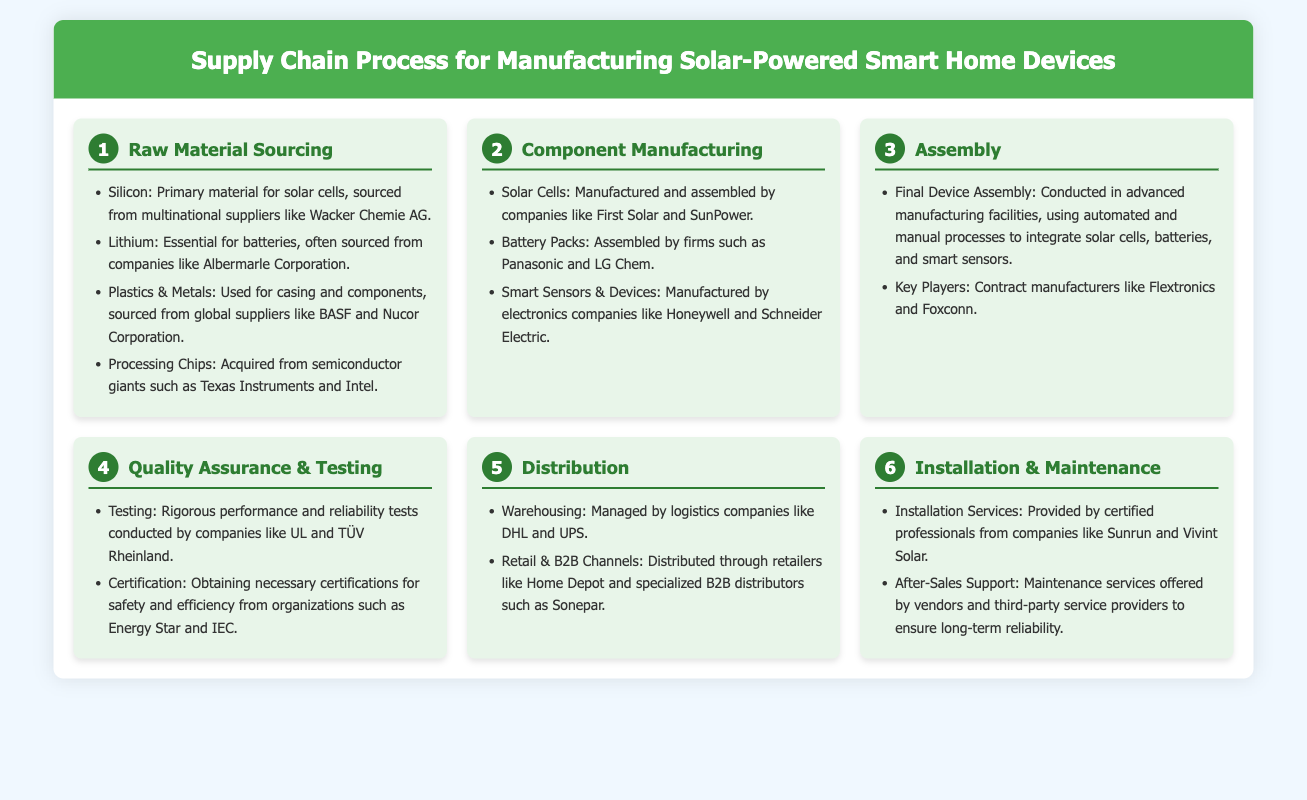What are the primary materials for solar cells? The primary materials for solar cells listed are Silicon, Lithium, Plastics & Metals, and Processing Chips.
Answer: Silicon, Lithium, Plastics & Metals, Processing Chips Which companies are involved in the manufacturing of solar cells? The companies mentioned that manufacture solar cells include First Solar and SunPower.
Answer: First Solar, SunPower What is the third step in the supply chain process? The third step in the supply chain process is Assembly.
Answer: Assembly What certification organizations are mentioned in the quality assurance process? The certification organizations mentioned for obtaining necessary certifications are Energy Star and IEC.
Answer: Energy Star, IEC Which logistics companies manage warehousing? The logistics companies managing warehousing mentioned are DHL and UPS.
Answer: DHL, UPS Which company provides installation services according to the process? The company that provides installation services mentioned is Sunrun.
Answer: Sunrun What role do contract manufacturers play in the assembly process? Contract manufacturers are key players in conducting the final device assembly.
Answer: Final device assembly What type of support is offered after installation? After installation, maintenance services are offered by vendors and third-party service providers.
Answer: Maintenance services 